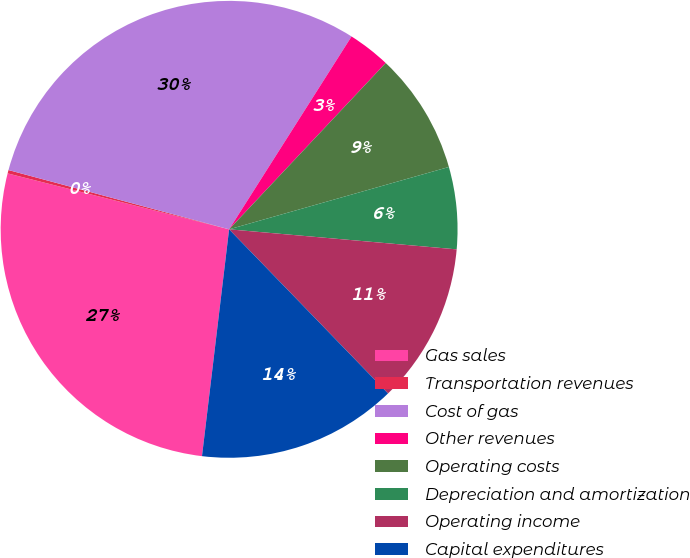Convert chart to OTSL. <chart><loc_0><loc_0><loc_500><loc_500><pie_chart><fcel>Gas sales<fcel>Transportation revenues<fcel>Cost of gas<fcel>Other revenues<fcel>Operating costs<fcel>Depreciation and amortization<fcel>Operating income<fcel>Capital expenditures<nl><fcel>27.05%<fcel>0.24%<fcel>29.83%<fcel>3.02%<fcel>8.58%<fcel>5.8%<fcel>11.36%<fcel>14.14%<nl></chart> 